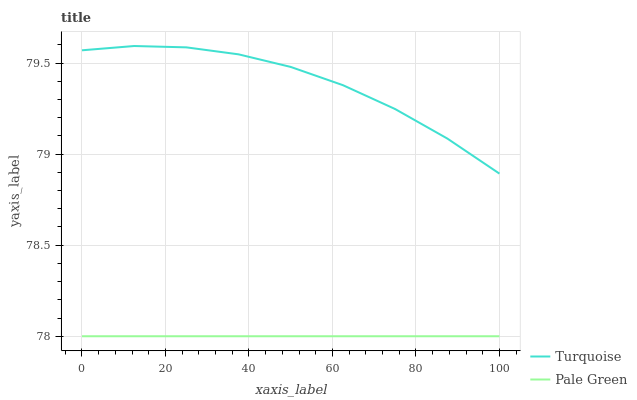Does Pale Green have the minimum area under the curve?
Answer yes or no. Yes. Does Turquoise have the maximum area under the curve?
Answer yes or no. Yes. Does Pale Green have the maximum area under the curve?
Answer yes or no. No. Is Pale Green the smoothest?
Answer yes or no. Yes. Is Turquoise the roughest?
Answer yes or no. Yes. Is Pale Green the roughest?
Answer yes or no. No. Does Pale Green have the highest value?
Answer yes or no. No. Is Pale Green less than Turquoise?
Answer yes or no. Yes. Is Turquoise greater than Pale Green?
Answer yes or no. Yes. Does Pale Green intersect Turquoise?
Answer yes or no. No. 